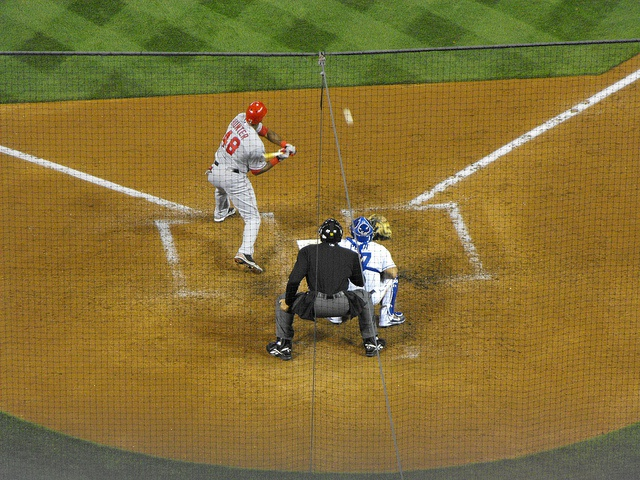Describe the objects in this image and their specific colors. I can see people in darkgreen, black, gray, olive, and lightgray tones, people in darkgreen, lightgray, darkgray, olive, and gray tones, people in darkgreen, white, gray, darkgray, and navy tones, baseball glove in darkgreen, olive, black, gray, and khaki tones, and baseball glove in darkgreen, lightgray, olive, darkgray, and gray tones in this image. 